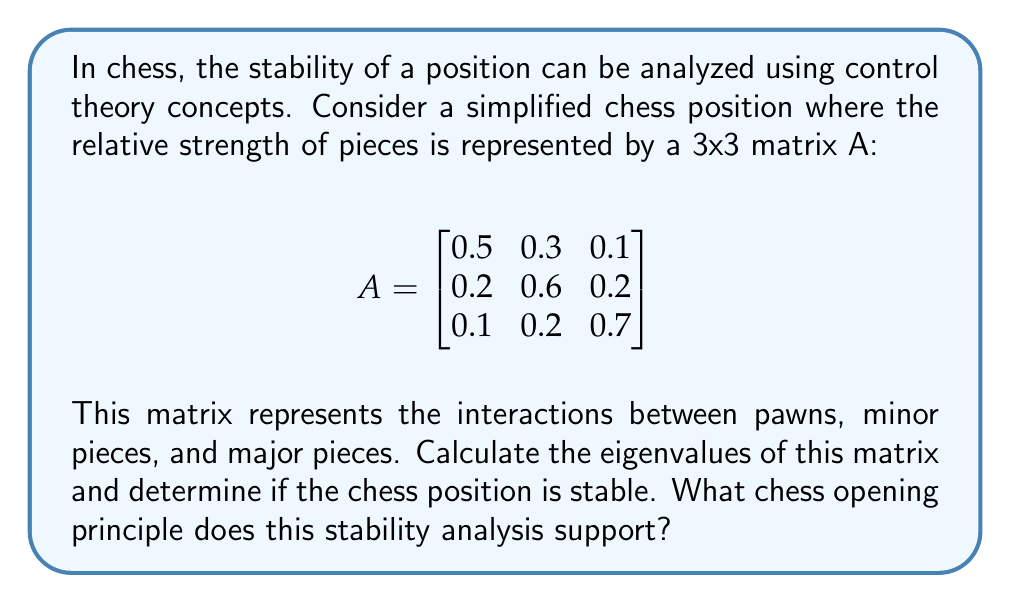Provide a solution to this math problem. To analyze the stability of the chess position using eigenvalues, we need to follow these steps:

1. Calculate the eigenvalues of matrix A.
2. Interpret the eigenvalues in terms of stability.
3. Relate the results to chess opening principles.

Step 1: Calculate the eigenvalues

To find the eigenvalues, we need to solve the characteristic equation:

$$det(A - \lambda I) = 0$$

Where $I$ is the 3x3 identity matrix and $\lambda$ represents the eigenvalues.

$$det\begin{bmatrix}
0.5-\lambda & 0.3 & 0.1 \\
0.2 & 0.6-\lambda & 0.2 \\
0.1 & 0.2 & 0.7-\lambda
\end{bmatrix} = 0$$

Expanding this determinant:

$$(0.5-\lambda)(0.6-\lambda)(0.7-\lambda) - 0.3\cdot0.2\cdot0.7 - 0.1\cdot0.6\cdot0.1 - 0.1\cdot0.2\cdot0.3 + 0.1\cdot0.2\cdot(0.6-\lambda) + 0.3\cdot0.2\cdot(0.7-\lambda) = 0$$

Simplifying:

$$-\lambda^3 + 1.8\lambda^2 - 1.07\lambda + 0.21 - 0.042 - 0.006 - 0.006 + 0.012 - 0.012\lambda + 0.042 - 0.042\lambda = 0$$

$$-\lambda^3 + 1.8\lambda^2 - 1.124\lambda + 0.206 = 0$$

Solving this cubic equation (using a numerical method or computer algebra system) gives us the eigenvalues:

$\lambda_1 \approx 0.9653$
$\lambda_2 \approx 0.5173$
$\lambda_3 \approx 0.3174$

Step 2: Interpret the eigenvalues

In control theory, a system is considered stable if all eigenvalues have magnitudes less than 1. In this case, all eigenvalues are real and positive, with magnitudes less than 1, indicating a stable system.

Step 3: Relate to chess opening principles

This stability analysis supports the chess opening principle of maintaining a balanced and controlled position. The eigenvalues being less than 1 suggest that no single aspect of the position (pawns, minor pieces, or major pieces) dominates excessively. This aligns with the principle of developing pieces harmoniously and maintaining a flexible pawn structure in the opening.

The largest eigenvalue (0.9653) being close to 1 indicates that the position is stable but dynamic, allowing for potential tactical opportunities without being overly rigid. This supports the idea of creating a solid foundation in the opening while preparing for middle game tactics.
Answer: The eigenvalues are approximately 0.9653, 0.5173, and 0.3174. Since all eigenvalues have magnitudes less than 1, the chess position is stable. This stability analysis supports the chess opening principle of maintaining a balanced and harmonious development of pieces while creating a flexible position that allows for tactical opportunities in the middle game. 